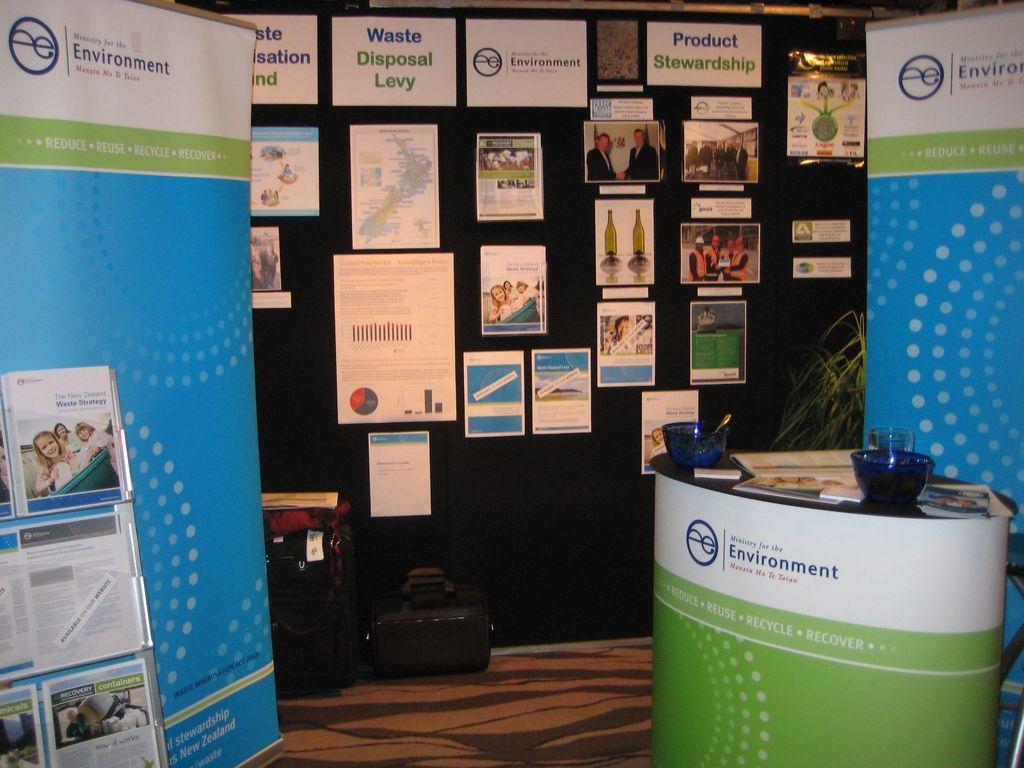The green desk is for what company?
Your response must be concise. Ministry for the environment. What type of levy is mentioned on the signs?
Offer a very short reply. Waste disposal. 